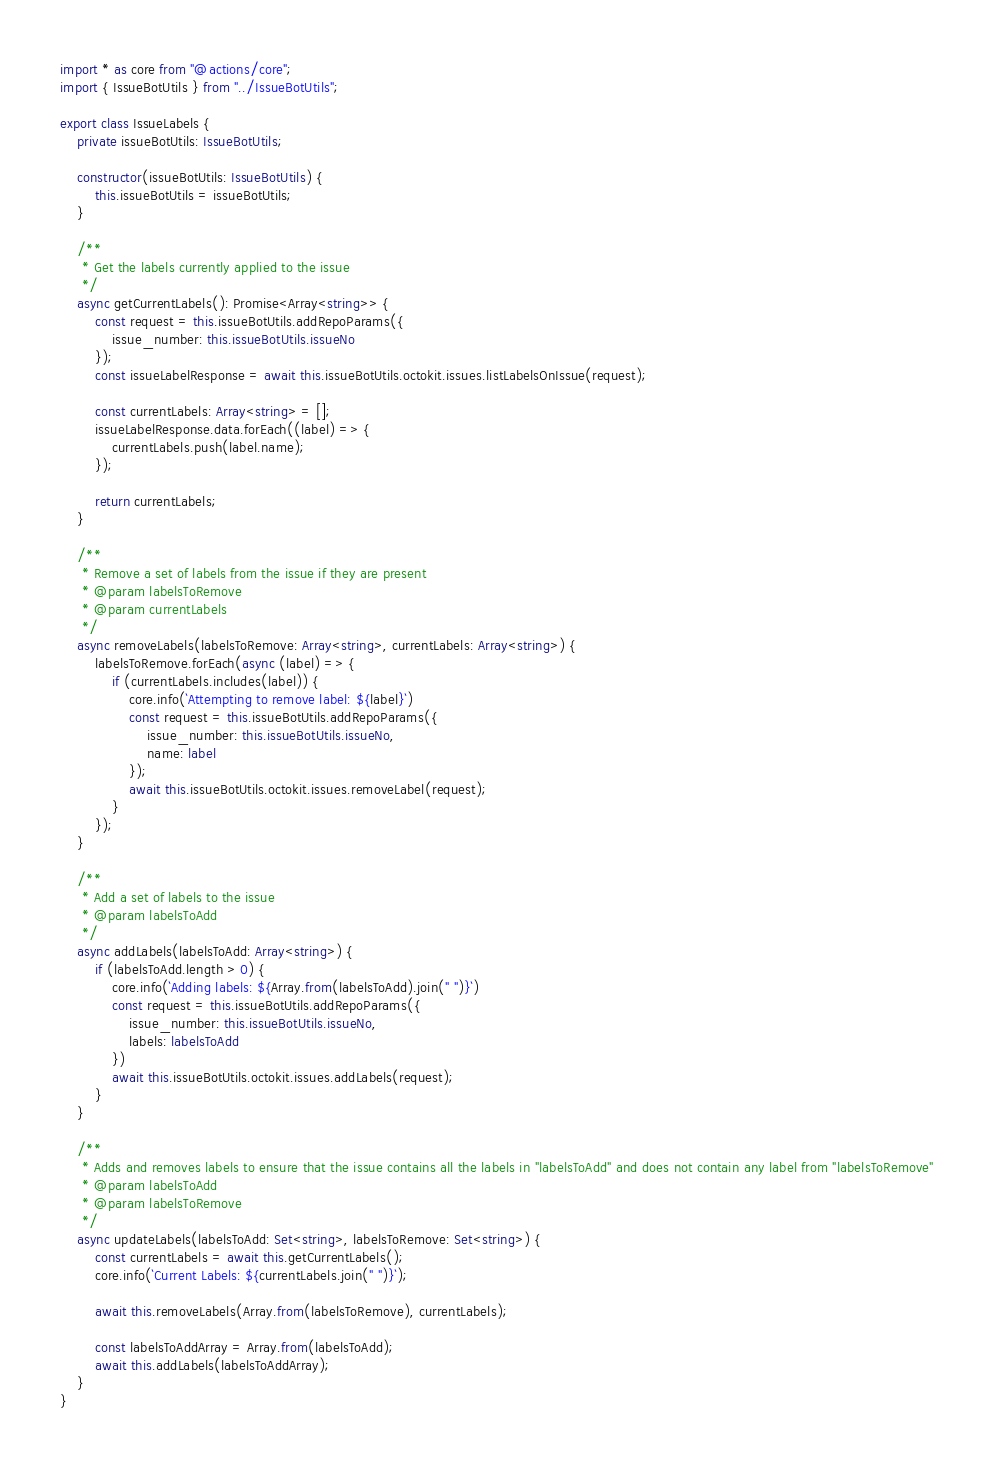Convert code to text. <code><loc_0><loc_0><loc_500><loc_500><_TypeScript_>import * as core from "@actions/core";
import { IssueBotUtils } from "../IssueBotUtils";

export class IssueLabels {
    private issueBotUtils: IssueBotUtils;

    constructor(issueBotUtils: IssueBotUtils) {
        this.issueBotUtils = issueBotUtils;
    }

    /**
     * Get the labels currently applied to the issue
     */
    async getCurrentLabels(): Promise<Array<string>> {
        const request = this.issueBotUtils.addRepoParams({
            issue_number: this.issueBotUtils.issueNo
        });
        const issueLabelResponse = await this.issueBotUtils.octokit.issues.listLabelsOnIssue(request);

        const currentLabels: Array<string> = [];
        issueLabelResponse.data.forEach((label) => {
            currentLabels.push(label.name);
        });

        return currentLabels;
    }

    /**
     * Remove a set of labels from the issue if they are present
     * @param labelsToRemove 
     * @param currentLabels 
     */
    async removeLabels(labelsToRemove: Array<string>, currentLabels: Array<string>) {
        labelsToRemove.forEach(async (label) => {
            if (currentLabels.includes(label)) {
                core.info(`Attempting to remove label: ${label}`)
                const request = this.issueBotUtils.addRepoParams({
                    issue_number: this.issueBotUtils.issueNo,
                    name: label
                });
                await this.issueBotUtils.octokit.issues.removeLabel(request);
            }
        });
    }

    /**
     * Add a set of labels to the issue
     * @param labelsToAdd 
     */
    async addLabels(labelsToAdd: Array<string>) {
        if (labelsToAdd.length > 0) {
            core.info(`Adding labels: ${Array.from(labelsToAdd).join(" ")}`)
            const request = this.issueBotUtils.addRepoParams({
                issue_number: this.issueBotUtils.issueNo,
                labels: labelsToAdd
            })
            await this.issueBotUtils.octokit.issues.addLabels(request);
        }
    }

    /**
     * Adds and removes labels to ensure that the issue contains all the labels in "labelsToAdd" and does not contain any label from "labelsToRemove"
     * @param labelsToAdd 
     * @param labelsToRemove 
     */
    async updateLabels(labelsToAdd: Set<string>, labelsToRemove: Set<string>) {
        const currentLabels = await this.getCurrentLabels();
        core.info(`Current Labels: ${currentLabels.join(" ")}`);

        await this.removeLabels(Array.from(labelsToRemove), currentLabels);
    
        const labelsToAddArray = Array.from(labelsToAdd);
        await this.addLabels(labelsToAddArray);
    }
}</code> 